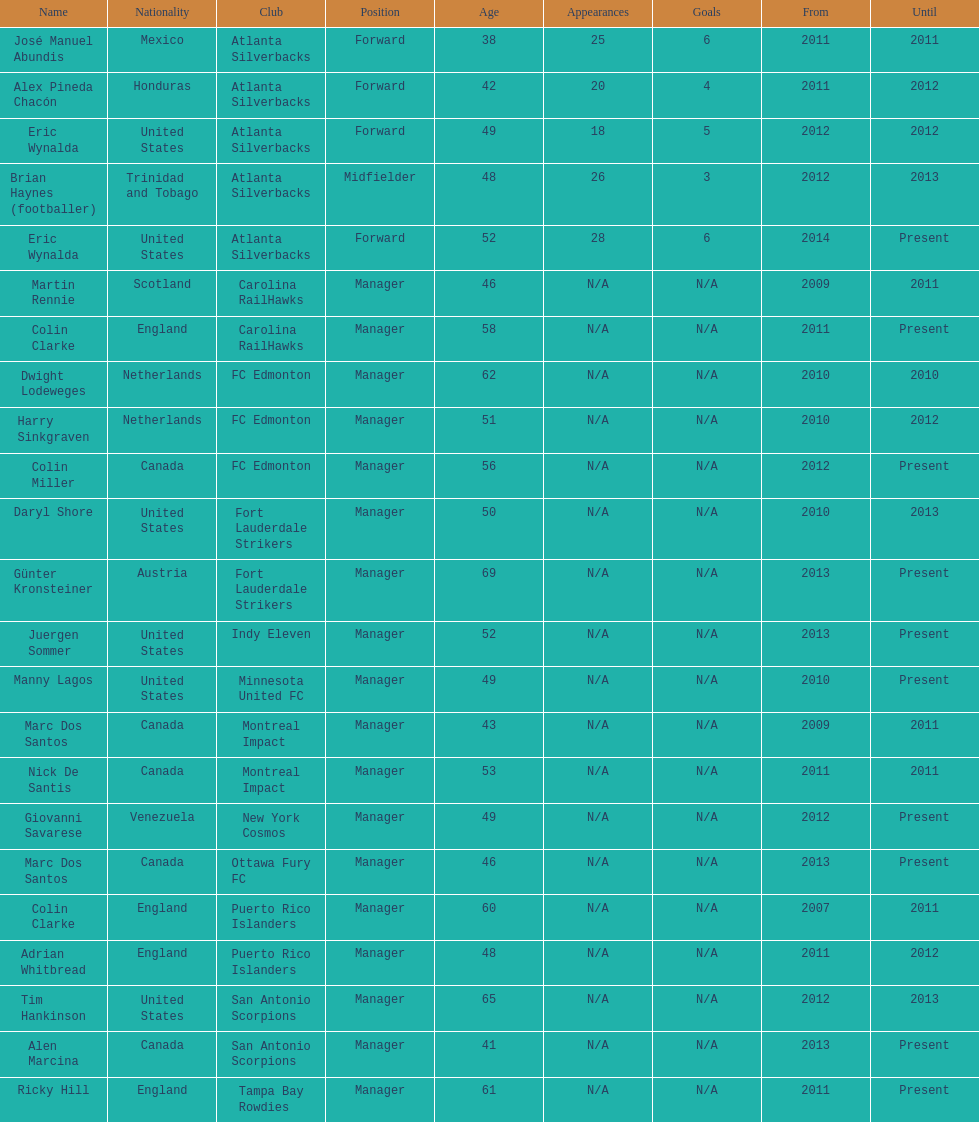Marc dos santos began coaching in the same year as which other coach? Martin Rennie. 